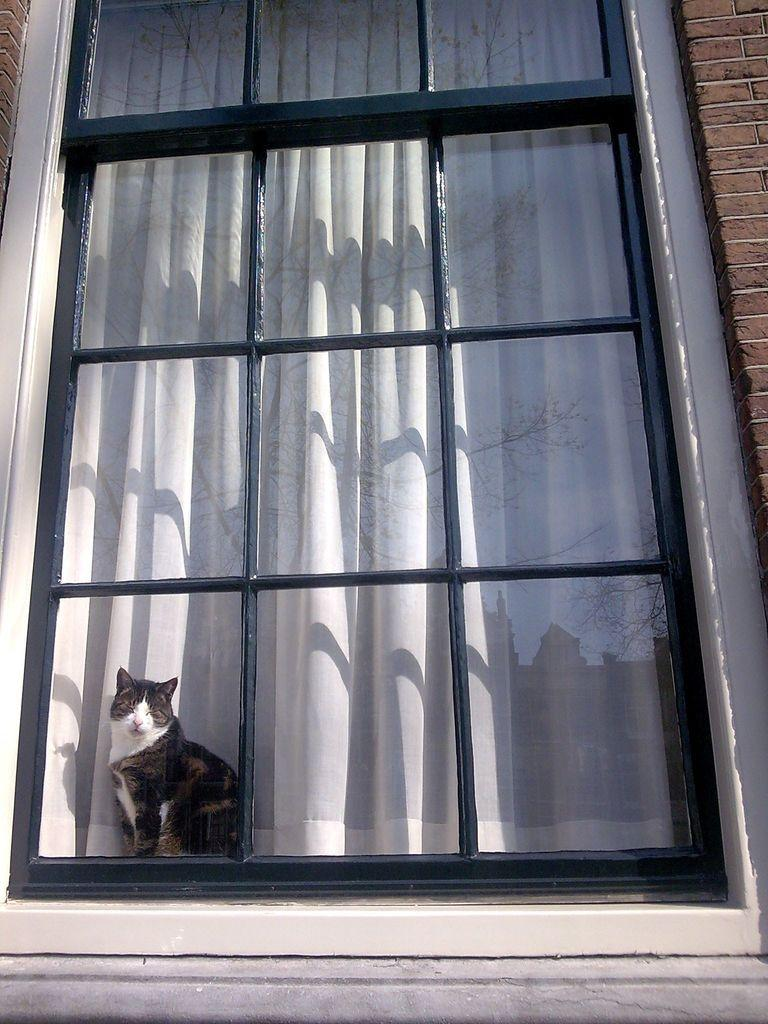What type of animal is in the image? There is a cat in the image. Where is the cat located in the image? The cat is in a glass window. What is behind the cat in the image? There is a curtain behind the cat in the image. What type of parent can be seen in the image? There is no parent present in the image; it features a cat in a glass window with a curtain behind it. What type of sand can be seen in the image? There is no sand present in the image. 